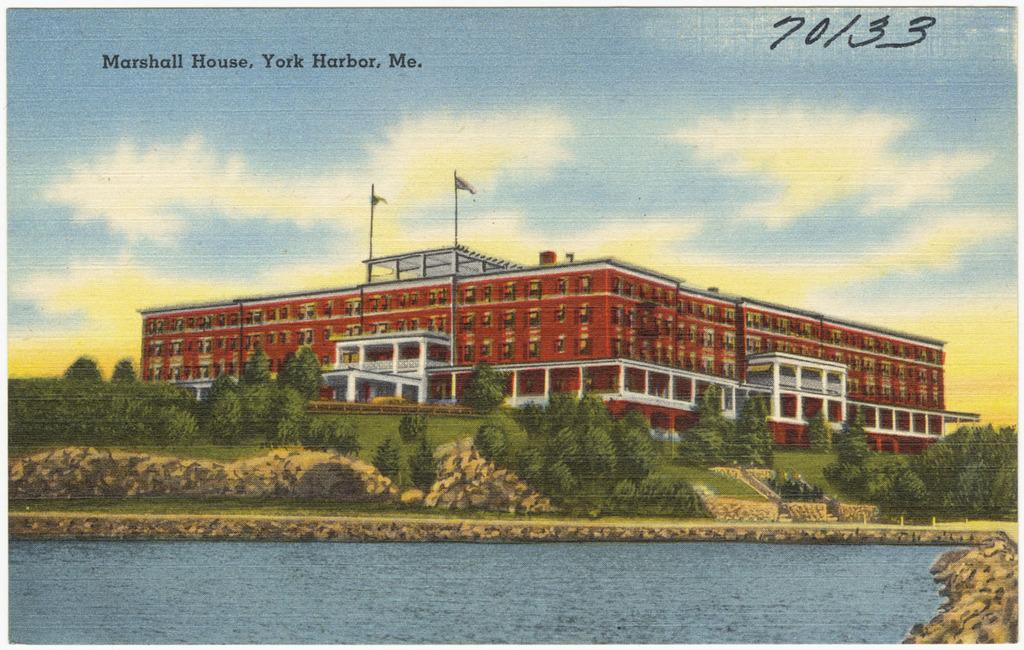<image>
Create a compact narrative representing the image presented. An old building which is the Marshal House in York Harbor, ME 